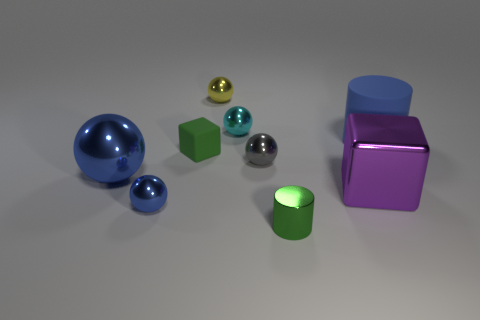Subtract all small yellow balls. How many balls are left? 4 Subtract 2 spheres. How many spheres are left? 3 Subtract all cyan balls. How many balls are left? 4 Subtract all red balls. Subtract all purple cylinders. How many balls are left? 5 Subtract all cubes. How many objects are left? 7 Add 1 tiny gray metallic things. How many tiny gray metallic things exist? 2 Subtract 0 red balls. How many objects are left? 9 Subtract all green cylinders. Subtract all small cyan metallic things. How many objects are left? 7 Add 6 blue cylinders. How many blue cylinders are left? 7 